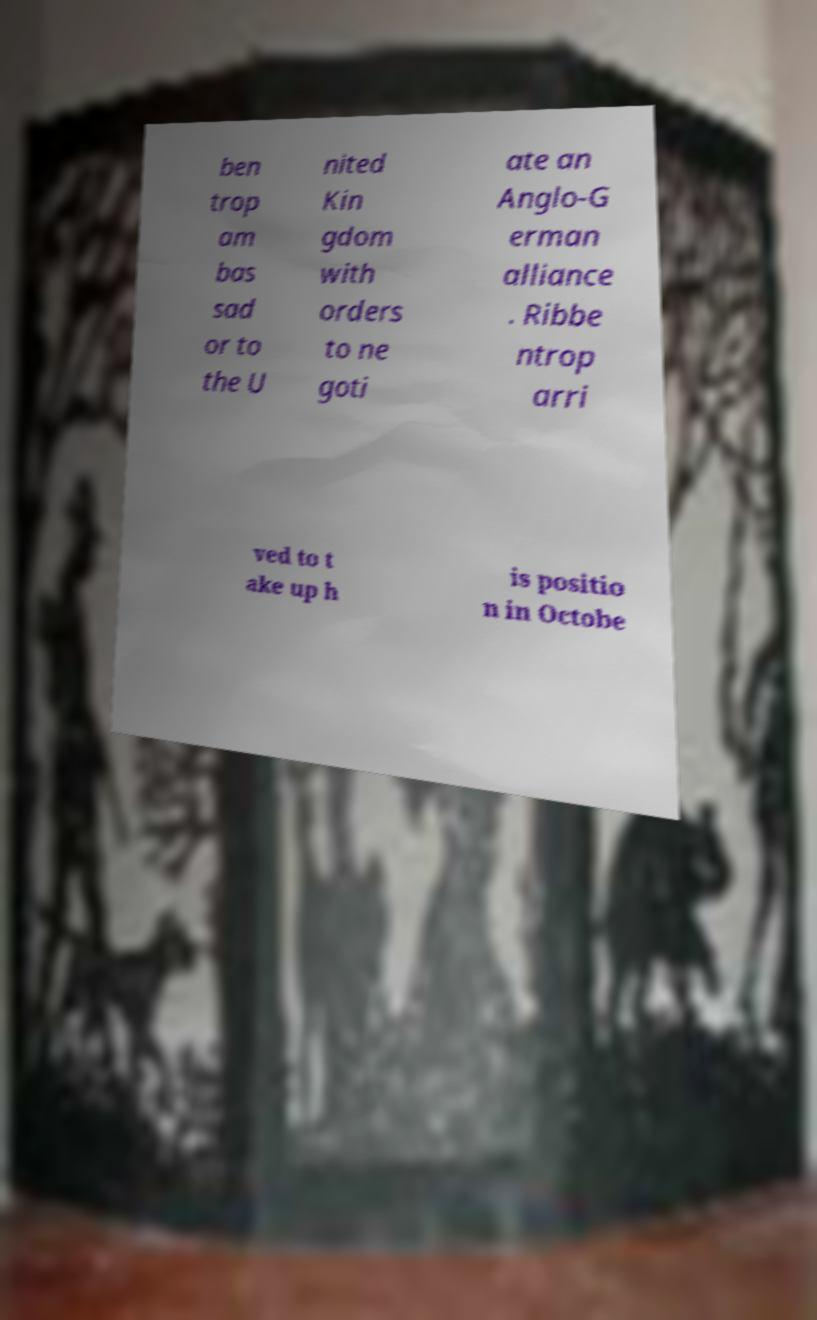What messages or text are displayed in this image? I need them in a readable, typed format. ben trop am bas sad or to the U nited Kin gdom with orders to ne goti ate an Anglo-G erman alliance . Ribbe ntrop arri ved to t ake up h is positio n in Octobe 